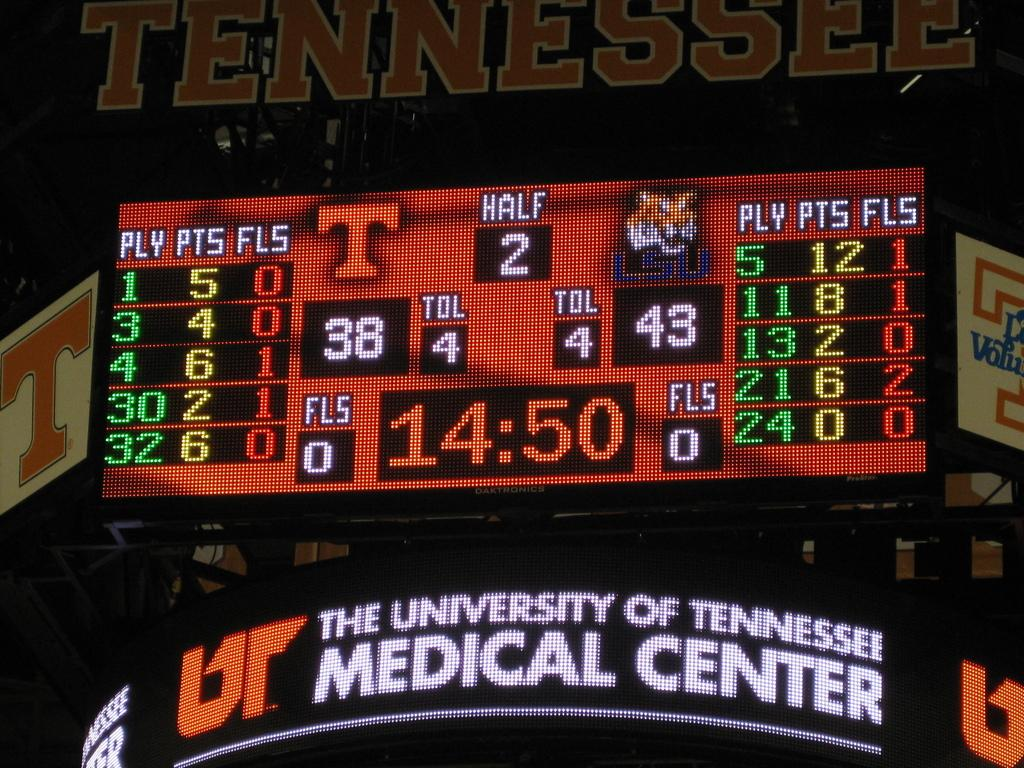<image>
Relay a brief, clear account of the picture shown. A digital sign for the University of Tennesse's Medical Center. 